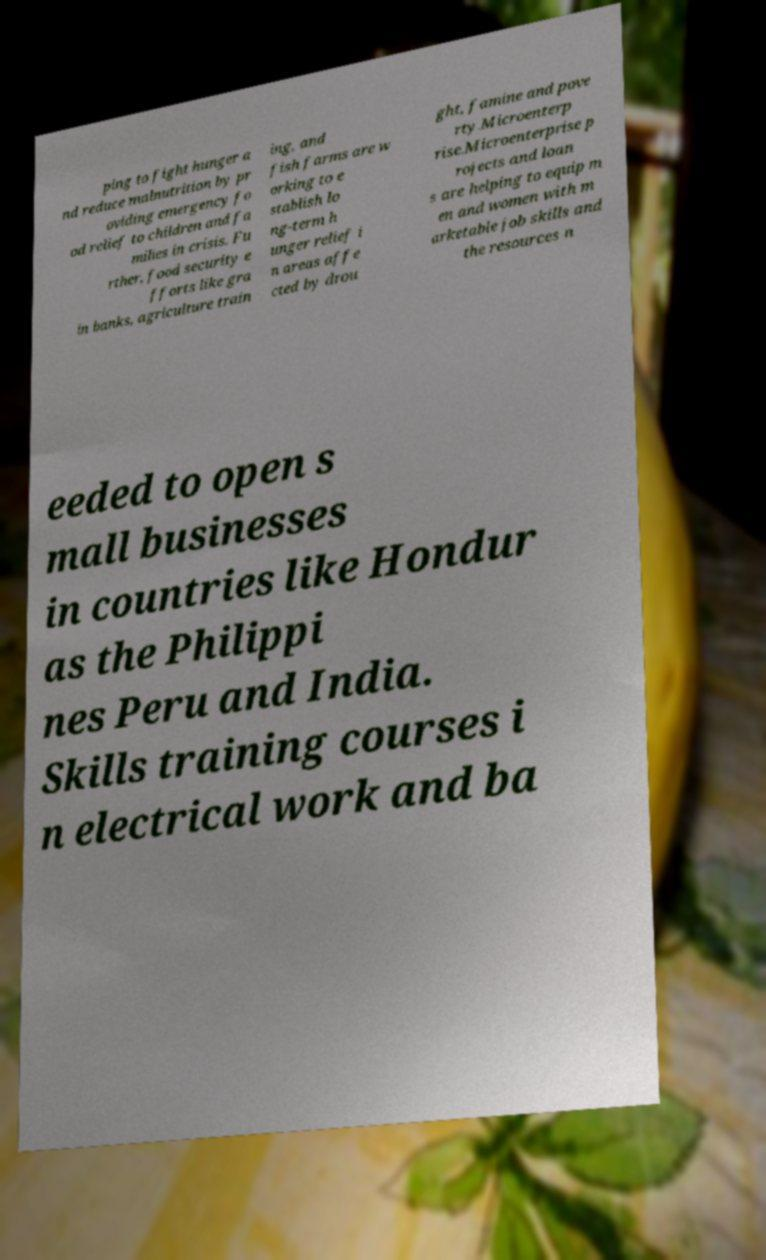There's text embedded in this image that I need extracted. Can you transcribe it verbatim? ping to fight hunger a nd reduce malnutrition by pr oviding emergency fo od relief to children and fa milies in crisis. Fu rther, food security e fforts like gra in banks, agriculture train ing, and fish farms are w orking to e stablish lo ng-term h unger relief i n areas affe cted by drou ght, famine and pove rty.Microenterp rise.Microenterprise p rojects and loan s are helping to equip m en and women with m arketable job skills and the resources n eeded to open s mall businesses in countries like Hondur as the Philippi nes Peru and India. Skills training courses i n electrical work and ba 